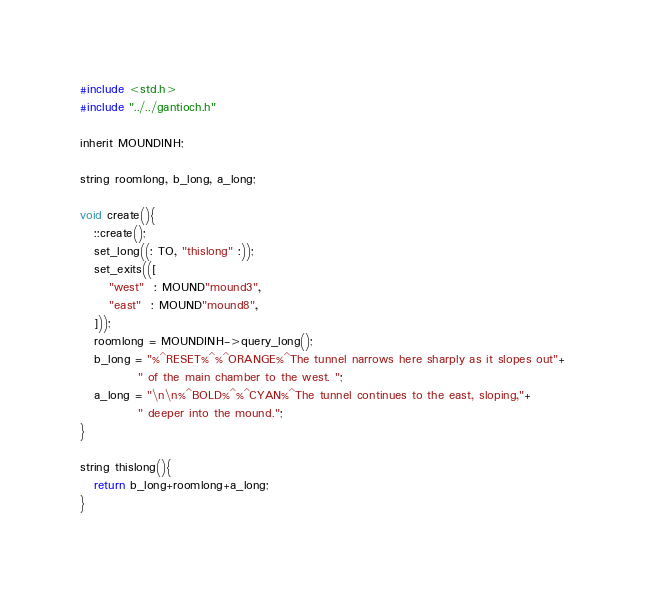Convert code to text. <code><loc_0><loc_0><loc_500><loc_500><_C_>#include <std.h>
#include "../../gantioch.h"

inherit MOUNDINH;

string roomlong, b_long, a_long;

void create(){
   ::create();
   set_long((: TO, "thislong" :));
   set_exits(([
      "west"  : MOUND"mound3",
      "east"  : MOUND"mound8",
   ]));
   roomlong = MOUNDINH->query_long();
   b_long = "%^RESET%^%^ORANGE%^The tunnel narrows here sharply as it slopes out"+
            " of the main chamber to the west. ";
   a_long = "\n\n%^BOLD%^%^CYAN%^The tunnel continues to the east, sloping,"+
            " deeper into the mound.";
}

string thislong(){
   return b_long+roomlong+a_long;
}
</code> 